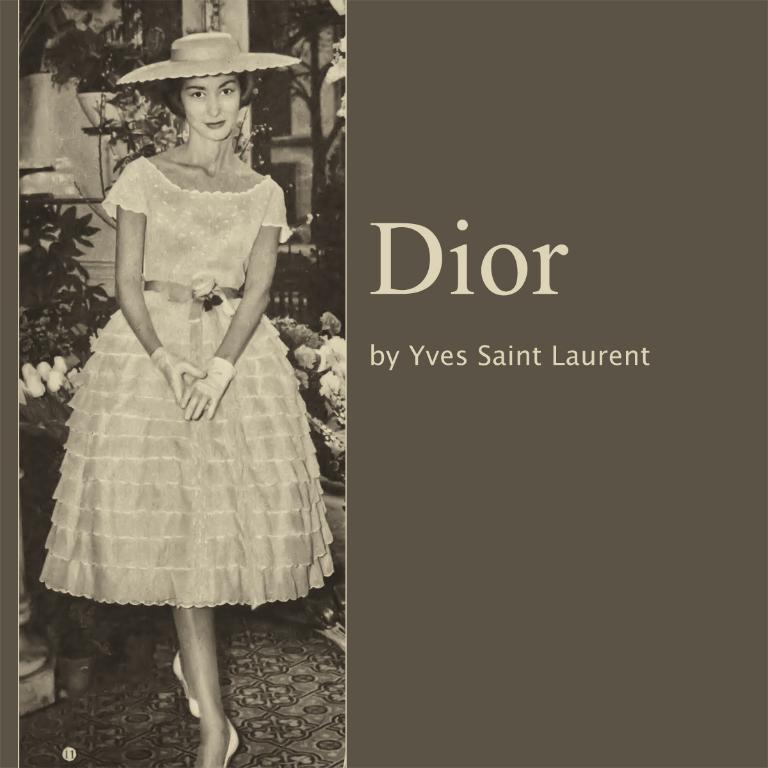<image>
Render a clear and concise summary of the photo. A woman is on the cover of Dior by Yves Saint Laurent. 